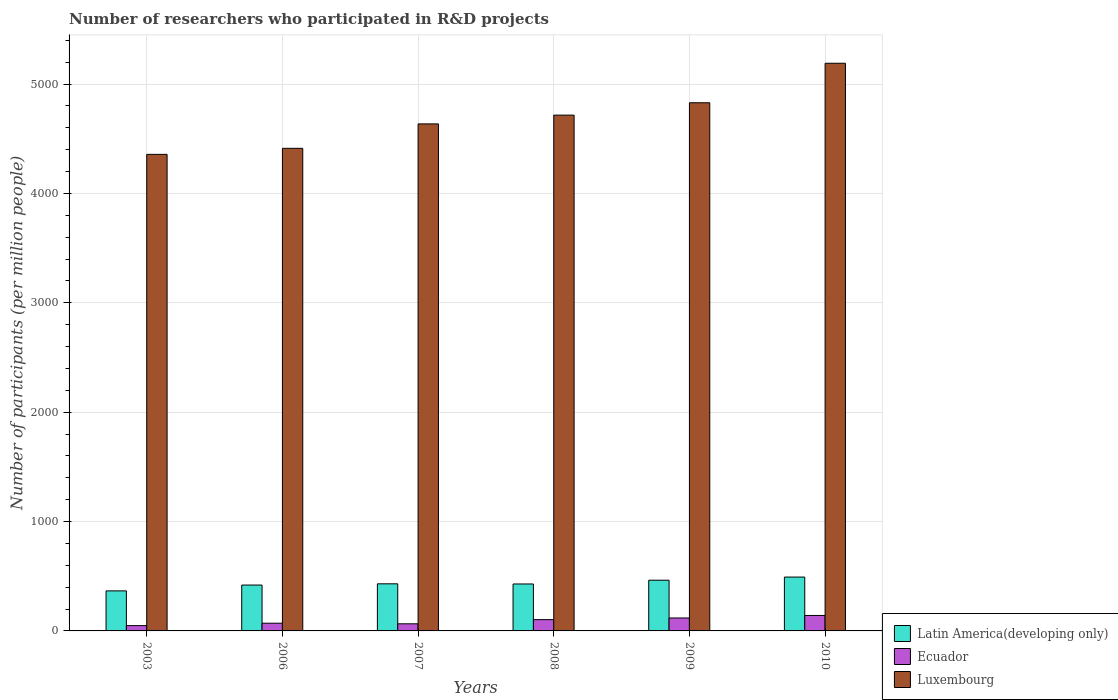How many different coloured bars are there?
Your answer should be very brief. 3. Are the number of bars per tick equal to the number of legend labels?
Your answer should be very brief. Yes. Are the number of bars on each tick of the X-axis equal?
Offer a very short reply. Yes. What is the label of the 5th group of bars from the left?
Offer a very short reply. 2009. In how many cases, is the number of bars for a given year not equal to the number of legend labels?
Offer a terse response. 0. What is the number of researchers who participated in R&D projects in Latin America(developing only) in 2008?
Offer a terse response. 429.22. Across all years, what is the maximum number of researchers who participated in R&D projects in Luxembourg?
Make the answer very short. 5190.11. Across all years, what is the minimum number of researchers who participated in R&D projects in Luxembourg?
Make the answer very short. 4357.05. In which year was the number of researchers who participated in R&D projects in Latin America(developing only) minimum?
Provide a short and direct response. 2003. What is the total number of researchers who participated in R&D projects in Luxembourg in the graph?
Make the answer very short. 2.81e+04. What is the difference between the number of researchers who participated in R&D projects in Ecuador in 2003 and that in 2008?
Keep it short and to the point. -54.7. What is the difference between the number of researchers who participated in R&D projects in Luxembourg in 2008 and the number of researchers who participated in R&D projects in Latin America(developing only) in 2003?
Keep it short and to the point. 4349.91. What is the average number of researchers who participated in R&D projects in Ecuador per year?
Offer a terse response. 91.16. In the year 2006, what is the difference between the number of researchers who participated in R&D projects in Latin America(developing only) and number of researchers who participated in R&D projects in Luxembourg?
Give a very brief answer. -3993.15. What is the ratio of the number of researchers who participated in R&D projects in Latin America(developing only) in 2007 to that in 2010?
Give a very brief answer. 0.87. What is the difference between the highest and the second highest number of researchers who participated in R&D projects in Luxembourg?
Offer a terse response. 361.16. What is the difference between the highest and the lowest number of researchers who participated in R&D projects in Luxembourg?
Your answer should be compact. 833.06. In how many years, is the number of researchers who participated in R&D projects in Latin America(developing only) greater than the average number of researchers who participated in R&D projects in Latin America(developing only) taken over all years?
Your answer should be compact. 2. Is the sum of the number of researchers who participated in R&D projects in Luxembourg in 2007 and 2010 greater than the maximum number of researchers who participated in R&D projects in Ecuador across all years?
Give a very brief answer. Yes. What does the 1st bar from the left in 2008 represents?
Your answer should be very brief. Latin America(developing only). What does the 1st bar from the right in 2008 represents?
Keep it short and to the point. Luxembourg. Is it the case that in every year, the sum of the number of researchers who participated in R&D projects in Luxembourg and number of researchers who participated in R&D projects in Latin America(developing only) is greater than the number of researchers who participated in R&D projects in Ecuador?
Make the answer very short. Yes. What is the difference between two consecutive major ticks on the Y-axis?
Offer a terse response. 1000. Are the values on the major ticks of Y-axis written in scientific E-notation?
Your response must be concise. No. How many legend labels are there?
Offer a very short reply. 3. How are the legend labels stacked?
Offer a very short reply. Vertical. What is the title of the graph?
Ensure brevity in your answer.  Number of researchers who participated in R&D projects. Does "Trinidad and Tobago" appear as one of the legend labels in the graph?
Offer a terse response. No. What is the label or title of the Y-axis?
Offer a terse response. Number of participants (per million people). What is the Number of participants (per million people) of Latin America(developing only) in 2003?
Your answer should be compact. 366.02. What is the Number of participants (per million people) in Ecuador in 2003?
Provide a succinct answer. 48.53. What is the Number of participants (per million people) of Luxembourg in 2003?
Offer a terse response. 4357.05. What is the Number of participants (per million people) in Latin America(developing only) in 2006?
Your answer should be very brief. 419.31. What is the Number of participants (per million people) of Ecuador in 2006?
Provide a succinct answer. 70.52. What is the Number of participants (per million people) in Luxembourg in 2006?
Your answer should be very brief. 4412.45. What is the Number of participants (per million people) of Latin America(developing only) in 2007?
Give a very brief answer. 430.59. What is the Number of participants (per million people) of Ecuador in 2007?
Make the answer very short. 65.05. What is the Number of participants (per million people) in Luxembourg in 2007?
Give a very brief answer. 4635.72. What is the Number of participants (per million people) of Latin America(developing only) in 2008?
Offer a terse response. 429.22. What is the Number of participants (per million people) in Ecuador in 2008?
Your response must be concise. 103.23. What is the Number of participants (per million people) of Luxembourg in 2008?
Keep it short and to the point. 4715.93. What is the Number of participants (per million people) in Latin America(developing only) in 2009?
Your response must be concise. 463.63. What is the Number of participants (per million people) in Ecuador in 2009?
Your response must be concise. 118.35. What is the Number of participants (per million people) in Luxembourg in 2009?
Give a very brief answer. 4828.95. What is the Number of participants (per million people) in Latin America(developing only) in 2010?
Your response must be concise. 492.36. What is the Number of participants (per million people) of Ecuador in 2010?
Ensure brevity in your answer.  141.3. What is the Number of participants (per million people) of Luxembourg in 2010?
Your response must be concise. 5190.11. Across all years, what is the maximum Number of participants (per million people) in Latin America(developing only)?
Offer a very short reply. 492.36. Across all years, what is the maximum Number of participants (per million people) in Ecuador?
Your answer should be compact. 141.3. Across all years, what is the maximum Number of participants (per million people) in Luxembourg?
Keep it short and to the point. 5190.11. Across all years, what is the minimum Number of participants (per million people) of Latin America(developing only)?
Make the answer very short. 366.02. Across all years, what is the minimum Number of participants (per million people) of Ecuador?
Ensure brevity in your answer.  48.53. Across all years, what is the minimum Number of participants (per million people) of Luxembourg?
Provide a succinct answer. 4357.05. What is the total Number of participants (per million people) of Latin America(developing only) in the graph?
Make the answer very short. 2601.13. What is the total Number of participants (per million people) of Ecuador in the graph?
Provide a succinct answer. 546.98. What is the total Number of participants (per million people) of Luxembourg in the graph?
Provide a short and direct response. 2.81e+04. What is the difference between the Number of participants (per million people) in Latin America(developing only) in 2003 and that in 2006?
Keep it short and to the point. -53.29. What is the difference between the Number of participants (per million people) of Ecuador in 2003 and that in 2006?
Your response must be concise. -21.99. What is the difference between the Number of participants (per million people) of Luxembourg in 2003 and that in 2006?
Provide a short and direct response. -55.4. What is the difference between the Number of participants (per million people) of Latin America(developing only) in 2003 and that in 2007?
Offer a very short reply. -64.56. What is the difference between the Number of participants (per million people) in Ecuador in 2003 and that in 2007?
Make the answer very short. -16.51. What is the difference between the Number of participants (per million people) of Luxembourg in 2003 and that in 2007?
Make the answer very short. -278.67. What is the difference between the Number of participants (per million people) in Latin America(developing only) in 2003 and that in 2008?
Provide a succinct answer. -63.2. What is the difference between the Number of participants (per million people) of Ecuador in 2003 and that in 2008?
Provide a short and direct response. -54.7. What is the difference between the Number of participants (per million people) in Luxembourg in 2003 and that in 2008?
Your response must be concise. -358.88. What is the difference between the Number of participants (per million people) in Latin America(developing only) in 2003 and that in 2009?
Give a very brief answer. -97.6. What is the difference between the Number of participants (per million people) of Ecuador in 2003 and that in 2009?
Your answer should be very brief. -69.82. What is the difference between the Number of participants (per million people) of Luxembourg in 2003 and that in 2009?
Provide a succinct answer. -471.9. What is the difference between the Number of participants (per million people) of Latin America(developing only) in 2003 and that in 2010?
Give a very brief answer. -126.34. What is the difference between the Number of participants (per million people) in Ecuador in 2003 and that in 2010?
Provide a succinct answer. -92.77. What is the difference between the Number of participants (per million people) of Luxembourg in 2003 and that in 2010?
Your response must be concise. -833.06. What is the difference between the Number of participants (per million people) of Latin America(developing only) in 2006 and that in 2007?
Your answer should be compact. -11.28. What is the difference between the Number of participants (per million people) of Ecuador in 2006 and that in 2007?
Make the answer very short. 5.48. What is the difference between the Number of participants (per million people) of Luxembourg in 2006 and that in 2007?
Make the answer very short. -223.27. What is the difference between the Number of participants (per million people) of Latin America(developing only) in 2006 and that in 2008?
Offer a very short reply. -9.91. What is the difference between the Number of participants (per million people) in Ecuador in 2006 and that in 2008?
Your answer should be compact. -32.71. What is the difference between the Number of participants (per million people) in Luxembourg in 2006 and that in 2008?
Offer a very short reply. -303.48. What is the difference between the Number of participants (per million people) in Latin America(developing only) in 2006 and that in 2009?
Your answer should be very brief. -44.32. What is the difference between the Number of participants (per million people) of Ecuador in 2006 and that in 2009?
Your answer should be compact. -47.83. What is the difference between the Number of participants (per million people) of Luxembourg in 2006 and that in 2009?
Ensure brevity in your answer.  -416.5. What is the difference between the Number of participants (per million people) in Latin America(developing only) in 2006 and that in 2010?
Provide a succinct answer. -73.06. What is the difference between the Number of participants (per million people) of Ecuador in 2006 and that in 2010?
Provide a short and direct response. -70.78. What is the difference between the Number of participants (per million people) in Luxembourg in 2006 and that in 2010?
Provide a short and direct response. -777.66. What is the difference between the Number of participants (per million people) in Latin America(developing only) in 2007 and that in 2008?
Ensure brevity in your answer.  1.37. What is the difference between the Number of participants (per million people) of Ecuador in 2007 and that in 2008?
Provide a short and direct response. -38.19. What is the difference between the Number of participants (per million people) in Luxembourg in 2007 and that in 2008?
Offer a very short reply. -80.21. What is the difference between the Number of participants (per million people) of Latin America(developing only) in 2007 and that in 2009?
Your answer should be compact. -33.04. What is the difference between the Number of participants (per million people) of Ecuador in 2007 and that in 2009?
Provide a short and direct response. -53.3. What is the difference between the Number of participants (per million people) of Luxembourg in 2007 and that in 2009?
Ensure brevity in your answer.  -193.23. What is the difference between the Number of participants (per million people) in Latin America(developing only) in 2007 and that in 2010?
Keep it short and to the point. -61.78. What is the difference between the Number of participants (per million people) in Ecuador in 2007 and that in 2010?
Offer a very short reply. -76.25. What is the difference between the Number of participants (per million people) of Luxembourg in 2007 and that in 2010?
Give a very brief answer. -554.39. What is the difference between the Number of participants (per million people) of Latin America(developing only) in 2008 and that in 2009?
Provide a succinct answer. -34.4. What is the difference between the Number of participants (per million people) in Ecuador in 2008 and that in 2009?
Your response must be concise. -15.12. What is the difference between the Number of participants (per million people) of Luxembourg in 2008 and that in 2009?
Provide a short and direct response. -113.02. What is the difference between the Number of participants (per million people) in Latin America(developing only) in 2008 and that in 2010?
Ensure brevity in your answer.  -63.14. What is the difference between the Number of participants (per million people) of Ecuador in 2008 and that in 2010?
Offer a terse response. -38.07. What is the difference between the Number of participants (per million people) in Luxembourg in 2008 and that in 2010?
Make the answer very short. -474.18. What is the difference between the Number of participants (per million people) in Latin America(developing only) in 2009 and that in 2010?
Ensure brevity in your answer.  -28.74. What is the difference between the Number of participants (per million people) of Ecuador in 2009 and that in 2010?
Offer a very short reply. -22.95. What is the difference between the Number of participants (per million people) of Luxembourg in 2009 and that in 2010?
Provide a succinct answer. -361.16. What is the difference between the Number of participants (per million people) in Latin America(developing only) in 2003 and the Number of participants (per million people) in Ecuador in 2006?
Ensure brevity in your answer.  295.5. What is the difference between the Number of participants (per million people) in Latin America(developing only) in 2003 and the Number of participants (per million people) in Luxembourg in 2006?
Provide a succinct answer. -4046.43. What is the difference between the Number of participants (per million people) of Ecuador in 2003 and the Number of participants (per million people) of Luxembourg in 2006?
Give a very brief answer. -4363.92. What is the difference between the Number of participants (per million people) in Latin America(developing only) in 2003 and the Number of participants (per million people) in Ecuador in 2007?
Provide a short and direct response. 300.98. What is the difference between the Number of participants (per million people) in Latin America(developing only) in 2003 and the Number of participants (per million people) in Luxembourg in 2007?
Your response must be concise. -4269.7. What is the difference between the Number of participants (per million people) of Ecuador in 2003 and the Number of participants (per million people) of Luxembourg in 2007?
Your answer should be compact. -4587.19. What is the difference between the Number of participants (per million people) of Latin America(developing only) in 2003 and the Number of participants (per million people) of Ecuador in 2008?
Your answer should be very brief. 262.79. What is the difference between the Number of participants (per million people) in Latin America(developing only) in 2003 and the Number of participants (per million people) in Luxembourg in 2008?
Ensure brevity in your answer.  -4349.91. What is the difference between the Number of participants (per million people) in Ecuador in 2003 and the Number of participants (per million people) in Luxembourg in 2008?
Offer a very short reply. -4667.4. What is the difference between the Number of participants (per million people) of Latin America(developing only) in 2003 and the Number of participants (per million people) of Ecuador in 2009?
Give a very brief answer. 247.67. What is the difference between the Number of participants (per million people) in Latin America(developing only) in 2003 and the Number of participants (per million people) in Luxembourg in 2009?
Keep it short and to the point. -4462.93. What is the difference between the Number of participants (per million people) in Ecuador in 2003 and the Number of participants (per million people) in Luxembourg in 2009?
Keep it short and to the point. -4780.42. What is the difference between the Number of participants (per million people) in Latin America(developing only) in 2003 and the Number of participants (per million people) in Ecuador in 2010?
Your response must be concise. 224.72. What is the difference between the Number of participants (per million people) of Latin America(developing only) in 2003 and the Number of participants (per million people) of Luxembourg in 2010?
Ensure brevity in your answer.  -4824.09. What is the difference between the Number of participants (per million people) in Ecuador in 2003 and the Number of participants (per million people) in Luxembourg in 2010?
Make the answer very short. -5141.58. What is the difference between the Number of participants (per million people) of Latin America(developing only) in 2006 and the Number of participants (per million people) of Ecuador in 2007?
Your answer should be very brief. 354.26. What is the difference between the Number of participants (per million people) of Latin America(developing only) in 2006 and the Number of participants (per million people) of Luxembourg in 2007?
Provide a succinct answer. -4216.41. What is the difference between the Number of participants (per million people) in Ecuador in 2006 and the Number of participants (per million people) in Luxembourg in 2007?
Ensure brevity in your answer.  -4565.2. What is the difference between the Number of participants (per million people) of Latin America(developing only) in 2006 and the Number of participants (per million people) of Ecuador in 2008?
Your response must be concise. 316.07. What is the difference between the Number of participants (per million people) of Latin America(developing only) in 2006 and the Number of participants (per million people) of Luxembourg in 2008?
Provide a succinct answer. -4296.62. What is the difference between the Number of participants (per million people) in Ecuador in 2006 and the Number of participants (per million people) in Luxembourg in 2008?
Your response must be concise. -4645.41. What is the difference between the Number of participants (per million people) in Latin America(developing only) in 2006 and the Number of participants (per million people) in Ecuador in 2009?
Your response must be concise. 300.96. What is the difference between the Number of participants (per million people) in Latin America(developing only) in 2006 and the Number of participants (per million people) in Luxembourg in 2009?
Ensure brevity in your answer.  -4409.64. What is the difference between the Number of participants (per million people) in Ecuador in 2006 and the Number of participants (per million people) in Luxembourg in 2009?
Keep it short and to the point. -4758.43. What is the difference between the Number of participants (per million people) in Latin America(developing only) in 2006 and the Number of participants (per million people) in Ecuador in 2010?
Provide a short and direct response. 278.01. What is the difference between the Number of participants (per million people) in Latin America(developing only) in 2006 and the Number of participants (per million people) in Luxembourg in 2010?
Offer a very short reply. -4770.8. What is the difference between the Number of participants (per million people) in Ecuador in 2006 and the Number of participants (per million people) in Luxembourg in 2010?
Provide a short and direct response. -5119.59. What is the difference between the Number of participants (per million people) in Latin America(developing only) in 2007 and the Number of participants (per million people) in Ecuador in 2008?
Offer a very short reply. 327.35. What is the difference between the Number of participants (per million people) in Latin America(developing only) in 2007 and the Number of participants (per million people) in Luxembourg in 2008?
Make the answer very short. -4285.35. What is the difference between the Number of participants (per million people) in Ecuador in 2007 and the Number of participants (per million people) in Luxembourg in 2008?
Your answer should be very brief. -4650.89. What is the difference between the Number of participants (per million people) of Latin America(developing only) in 2007 and the Number of participants (per million people) of Ecuador in 2009?
Ensure brevity in your answer.  312.24. What is the difference between the Number of participants (per million people) in Latin America(developing only) in 2007 and the Number of participants (per million people) in Luxembourg in 2009?
Your answer should be very brief. -4398.36. What is the difference between the Number of participants (per million people) in Ecuador in 2007 and the Number of participants (per million people) in Luxembourg in 2009?
Your answer should be very brief. -4763.9. What is the difference between the Number of participants (per million people) of Latin America(developing only) in 2007 and the Number of participants (per million people) of Ecuador in 2010?
Ensure brevity in your answer.  289.29. What is the difference between the Number of participants (per million people) of Latin America(developing only) in 2007 and the Number of participants (per million people) of Luxembourg in 2010?
Provide a succinct answer. -4759.52. What is the difference between the Number of participants (per million people) of Ecuador in 2007 and the Number of participants (per million people) of Luxembourg in 2010?
Provide a succinct answer. -5125.07. What is the difference between the Number of participants (per million people) of Latin America(developing only) in 2008 and the Number of participants (per million people) of Ecuador in 2009?
Your answer should be very brief. 310.87. What is the difference between the Number of participants (per million people) of Latin America(developing only) in 2008 and the Number of participants (per million people) of Luxembourg in 2009?
Offer a very short reply. -4399.73. What is the difference between the Number of participants (per million people) in Ecuador in 2008 and the Number of participants (per million people) in Luxembourg in 2009?
Offer a very short reply. -4725.72. What is the difference between the Number of participants (per million people) of Latin America(developing only) in 2008 and the Number of participants (per million people) of Ecuador in 2010?
Provide a short and direct response. 287.92. What is the difference between the Number of participants (per million people) in Latin America(developing only) in 2008 and the Number of participants (per million people) in Luxembourg in 2010?
Ensure brevity in your answer.  -4760.89. What is the difference between the Number of participants (per million people) of Ecuador in 2008 and the Number of participants (per million people) of Luxembourg in 2010?
Provide a succinct answer. -5086.88. What is the difference between the Number of participants (per million people) in Latin America(developing only) in 2009 and the Number of participants (per million people) in Ecuador in 2010?
Provide a short and direct response. 322.33. What is the difference between the Number of participants (per million people) of Latin America(developing only) in 2009 and the Number of participants (per million people) of Luxembourg in 2010?
Keep it short and to the point. -4726.48. What is the difference between the Number of participants (per million people) of Ecuador in 2009 and the Number of participants (per million people) of Luxembourg in 2010?
Offer a terse response. -5071.76. What is the average Number of participants (per million people) in Latin America(developing only) per year?
Provide a succinct answer. 433.52. What is the average Number of participants (per million people) of Ecuador per year?
Provide a short and direct response. 91.16. What is the average Number of participants (per million people) in Luxembourg per year?
Your response must be concise. 4690.04. In the year 2003, what is the difference between the Number of participants (per million people) in Latin America(developing only) and Number of participants (per million people) in Ecuador?
Your answer should be compact. 317.49. In the year 2003, what is the difference between the Number of participants (per million people) of Latin America(developing only) and Number of participants (per million people) of Luxembourg?
Offer a very short reply. -3991.03. In the year 2003, what is the difference between the Number of participants (per million people) of Ecuador and Number of participants (per million people) of Luxembourg?
Give a very brief answer. -4308.52. In the year 2006, what is the difference between the Number of participants (per million people) of Latin America(developing only) and Number of participants (per million people) of Ecuador?
Offer a terse response. 348.79. In the year 2006, what is the difference between the Number of participants (per million people) of Latin America(developing only) and Number of participants (per million people) of Luxembourg?
Ensure brevity in your answer.  -3993.15. In the year 2006, what is the difference between the Number of participants (per million people) of Ecuador and Number of participants (per million people) of Luxembourg?
Make the answer very short. -4341.93. In the year 2007, what is the difference between the Number of participants (per million people) in Latin America(developing only) and Number of participants (per million people) in Ecuador?
Give a very brief answer. 365.54. In the year 2007, what is the difference between the Number of participants (per million people) of Latin America(developing only) and Number of participants (per million people) of Luxembourg?
Provide a short and direct response. -4205.13. In the year 2007, what is the difference between the Number of participants (per million people) of Ecuador and Number of participants (per million people) of Luxembourg?
Offer a very short reply. -4570.68. In the year 2008, what is the difference between the Number of participants (per million people) in Latin America(developing only) and Number of participants (per million people) in Ecuador?
Offer a very short reply. 325.99. In the year 2008, what is the difference between the Number of participants (per million people) in Latin America(developing only) and Number of participants (per million people) in Luxembourg?
Ensure brevity in your answer.  -4286.71. In the year 2008, what is the difference between the Number of participants (per million people) in Ecuador and Number of participants (per million people) in Luxembourg?
Give a very brief answer. -4612.7. In the year 2009, what is the difference between the Number of participants (per million people) of Latin America(developing only) and Number of participants (per million people) of Ecuador?
Give a very brief answer. 345.28. In the year 2009, what is the difference between the Number of participants (per million people) in Latin America(developing only) and Number of participants (per million people) in Luxembourg?
Provide a succinct answer. -4365.32. In the year 2009, what is the difference between the Number of participants (per million people) of Ecuador and Number of participants (per million people) of Luxembourg?
Your response must be concise. -4710.6. In the year 2010, what is the difference between the Number of participants (per million people) of Latin America(developing only) and Number of participants (per million people) of Ecuador?
Make the answer very short. 351.06. In the year 2010, what is the difference between the Number of participants (per million people) of Latin America(developing only) and Number of participants (per million people) of Luxembourg?
Your answer should be compact. -4697.75. In the year 2010, what is the difference between the Number of participants (per million people) of Ecuador and Number of participants (per million people) of Luxembourg?
Make the answer very short. -5048.81. What is the ratio of the Number of participants (per million people) in Latin America(developing only) in 2003 to that in 2006?
Provide a succinct answer. 0.87. What is the ratio of the Number of participants (per million people) in Ecuador in 2003 to that in 2006?
Make the answer very short. 0.69. What is the ratio of the Number of participants (per million people) of Luxembourg in 2003 to that in 2006?
Provide a short and direct response. 0.99. What is the ratio of the Number of participants (per million people) in Latin America(developing only) in 2003 to that in 2007?
Your response must be concise. 0.85. What is the ratio of the Number of participants (per million people) of Ecuador in 2003 to that in 2007?
Keep it short and to the point. 0.75. What is the ratio of the Number of participants (per million people) of Luxembourg in 2003 to that in 2007?
Offer a terse response. 0.94. What is the ratio of the Number of participants (per million people) in Latin America(developing only) in 2003 to that in 2008?
Your response must be concise. 0.85. What is the ratio of the Number of participants (per million people) in Ecuador in 2003 to that in 2008?
Provide a succinct answer. 0.47. What is the ratio of the Number of participants (per million people) of Luxembourg in 2003 to that in 2008?
Provide a succinct answer. 0.92. What is the ratio of the Number of participants (per million people) in Latin America(developing only) in 2003 to that in 2009?
Your response must be concise. 0.79. What is the ratio of the Number of participants (per million people) of Ecuador in 2003 to that in 2009?
Your answer should be very brief. 0.41. What is the ratio of the Number of participants (per million people) in Luxembourg in 2003 to that in 2009?
Provide a short and direct response. 0.9. What is the ratio of the Number of participants (per million people) in Latin America(developing only) in 2003 to that in 2010?
Provide a succinct answer. 0.74. What is the ratio of the Number of participants (per million people) of Ecuador in 2003 to that in 2010?
Your answer should be very brief. 0.34. What is the ratio of the Number of participants (per million people) of Luxembourg in 2003 to that in 2010?
Provide a short and direct response. 0.84. What is the ratio of the Number of participants (per million people) in Latin America(developing only) in 2006 to that in 2007?
Make the answer very short. 0.97. What is the ratio of the Number of participants (per million people) of Ecuador in 2006 to that in 2007?
Offer a very short reply. 1.08. What is the ratio of the Number of participants (per million people) of Luxembourg in 2006 to that in 2007?
Your answer should be very brief. 0.95. What is the ratio of the Number of participants (per million people) in Latin America(developing only) in 2006 to that in 2008?
Make the answer very short. 0.98. What is the ratio of the Number of participants (per million people) of Ecuador in 2006 to that in 2008?
Give a very brief answer. 0.68. What is the ratio of the Number of participants (per million people) of Luxembourg in 2006 to that in 2008?
Your answer should be compact. 0.94. What is the ratio of the Number of participants (per million people) in Latin America(developing only) in 2006 to that in 2009?
Offer a very short reply. 0.9. What is the ratio of the Number of participants (per million people) of Ecuador in 2006 to that in 2009?
Your answer should be very brief. 0.6. What is the ratio of the Number of participants (per million people) of Luxembourg in 2006 to that in 2009?
Make the answer very short. 0.91. What is the ratio of the Number of participants (per million people) of Latin America(developing only) in 2006 to that in 2010?
Provide a succinct answer. 0.85. What is the ratio of the Number of participants (per million people) of Ecuador in 2006 to that in 2010?
Your answer should be compact. 0.5. What is the ratio of the Number of participants (per million people) of Luxembourg in 2006 to that in 2010?
Offer a very short reply. 0.85. What is the ratio of the Number of participants (per million people) of Ecuador in 2007 to that in 2008?
Give a very brief answer. 0.63. What is the ratio of the Number of participants (per million people) in Luxembourg in 2007 to that in 2008?
Your response must be concise. 0.98. What is the ratio of the Number of participants (per million people) in Latin America(developing only) in 2007 to that in 2009?
Provide a succinct answer. 0.93. What is the ratio of the Number of participants (per million people) in Ecuador in 2007 to that in 2009?
Ensure brevity in your answer.  0.55. What is the ratio of the Number of participants (per million people) in Luxembourg in 2007 to that in 2009?
Offer a very short reply. 0.96. What is the ratio of the Number of participants (per million people) of Latin America(developing only) in 2007 to that in 2010?
Your answer should be compact. 0.87. What is the ratio of the Number of participants (per million people) of Ecuador in 2007 to that in 2010?
Provide a succinct answer. 0.46. What is the ratio of the Number of participants (per million people) of Luxembourg in 2007 to that in 2010?
Your response must be concise. 0.89. What is the ratio of the Number of participants (per million people) in Latin America(developing only) in 2008 to that in 2009?
Provide a succinct answer. 0.93. What is the ratio of the Number of participants (per million people) in Ecuador in 2008 to that in 2009?
Provide a short and direct response. 0.87. What is the ratio of the Number of participants (per million people) of Luxembourg in 2008 to that in 2009?
Ensure brevity in your answer.  0.98. What is the ratio of the Number of participants (per million people) of Latin America(developing only) in 2008 to that in 2010?
Ensure brevity in your answer.  0.87. What is the ratio of the Number of participants (per million people) in Ecuador in 2008 to that in 2010?
Your response must be concise. 0.73. What is the ratio of the Number of participants (per million people) in Luxembourg in 2008 to that in 2010?
Offer a very short reply. 0.91. What is the ratio of the Number of participants (per million people) of Latin America(developing only) in 2009 to that in 2010?
Ensure brevity in your answer.  0.94. What is the ratio of the Number of participants (per million people) of Ecuador in 2009 to that in 2010?
Your answer should be very brief. 0.84. What is the ratio of the Number of participants (per million people) in Luxembourg in 2009 to that in 2010?
Offer a terse response. 0.93. What is the difference between the highest and the second highest Number of participants (per million people) in Latin America(developing only)?
Your response must be concise. 28.74. What is the difference between the highest and the second highest Number of participants (per million people) in Ecuador?
Keep it short and to the point. 22.95. What is the difference between the highest and the second highest Number of participants (per million people) of Luxembourg?
Provide a succinct answer. 361.16. What is the difference between the highest and the lowest Number of participants (per million people) of Latin America(developing only)?
Offer a very short reply. 126.34. What is the difference between the highest and the lowest Number of participants (per million people) of Ecuador?
Provide a short and direct response. 92.77. What is the difference between the highest and the lowest Number of participants (per million people) of Luxembourg?
Give a very brief answer. 833.06. 